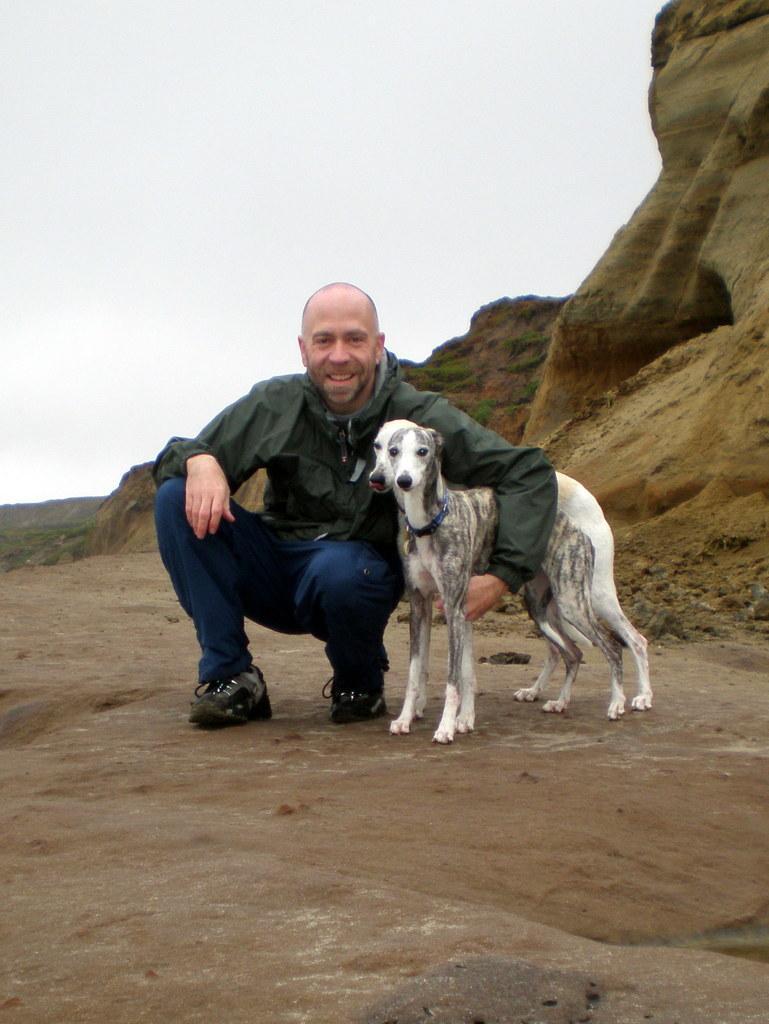In one or two sentences, can you explain what this image depicts? In this image there is a man squatting on a land holding two dogs with his hand, in the background there is a hill and the sky. 